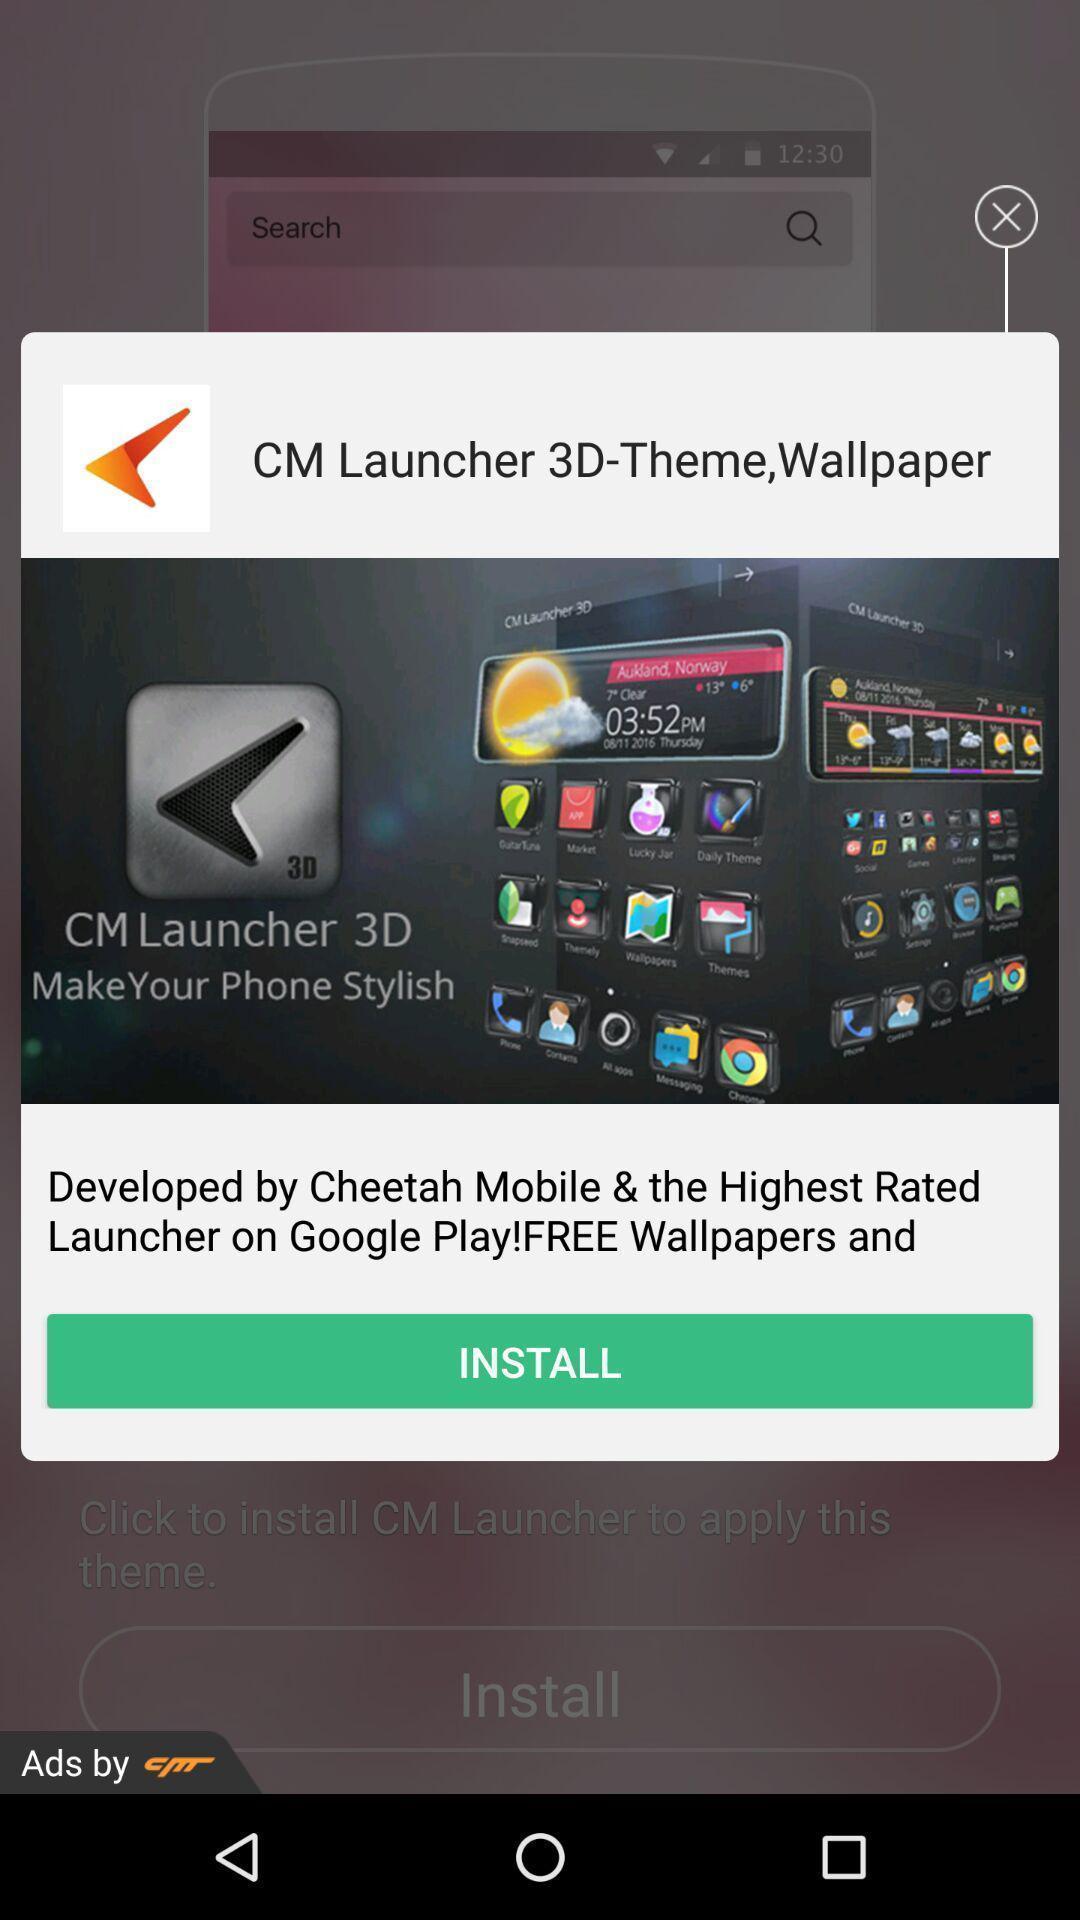Explain the elements present in this screenshot. Pop-up shows install option with some text and image. 